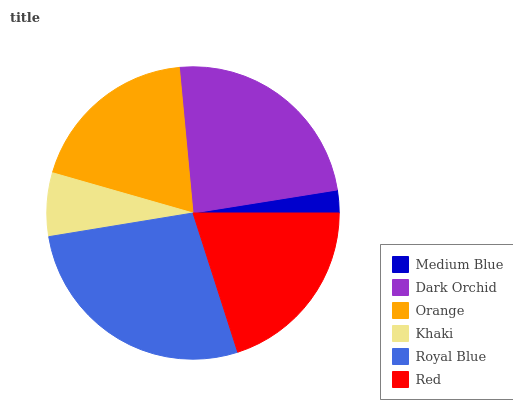Is Medium Blue the minimum?
Answer yes or no. Yes. Is Royal Blue the maximum?
Answer yes or no. Yes. Is Dark Orchid the minimum?
Answer yes or no. No. Is Dark Orchid the maximum?
Answer yes or no. No. Is Dark Orchid greater than Medium Blue?
Answer yes or no. Yes. Is Medium Blue less than Dark Orchid?
Answer yes or no. Yes. Is Medium Blue greater than Dark Orchid?
Answer yes or no. No. Is Dark Orchid less than Medium Blue?
Answer yes or no. No. Is Red the high median?
Answer yes or no. Yes. Is Orange the low median?
Answer yes or no. Yes. Is Khaki the high median?
Answer yes or no. No. Is Royal Blue the low median?
Answer yes or no. No. 